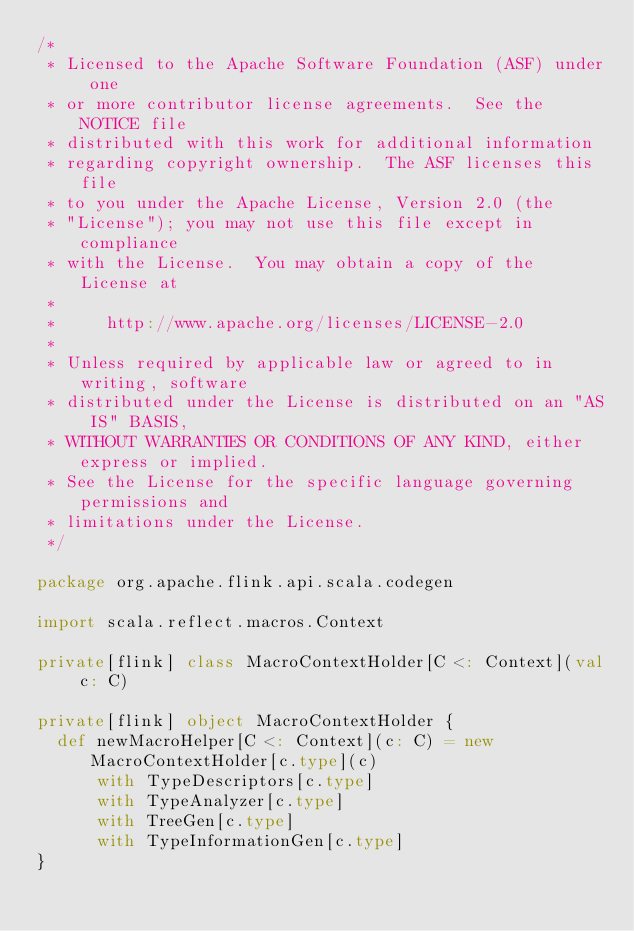<code> <loc_0><loc_0><loc_500><loc_500><_Scala_>/*
 * Licensed to the Apache Software Foundation (ASF) under one
 * or more contributor license agreements.  See the NOTICE file
 * distributed with this work for additional information
 * regarding copyright ownership.  The ASF licenses this file
 * to you under the Apache License, Version 2.0 (the
 * "License"); you may not use this file except in compliance
 * with the License.  You may obtain a copy of the License at
 *
 *     http://www.apache.org/licenses/LICENSE-2.0
 *
 * Unless required by applicable law or agreed to in writing, software
 * distributed under the License is distributed on an "AS IS" BASIS,
 * WITHOUT WARRANTIES OR CONDITIONS OF ANY KIND, either express or implied.
 * See the License for the specific language governing permissions and
 * limitations under the License.
 */

package org.apache.flink.api.scala.codegen

import scala.reflect.macros.Context

private[flink] class MacroContextHolder[C <: Context](val c: C)

private[flink] object MacroContextHolder {
  def newMacroHelper[C <: Context](c: C) = new MacroContextHolder[c.type](c)
      with TypeDescriptors[c.type]
      with TypeAnalyzer[c.type]
      with TreeGen[c.type]
      with TypeInformationGen[c.type]
}
</code> 